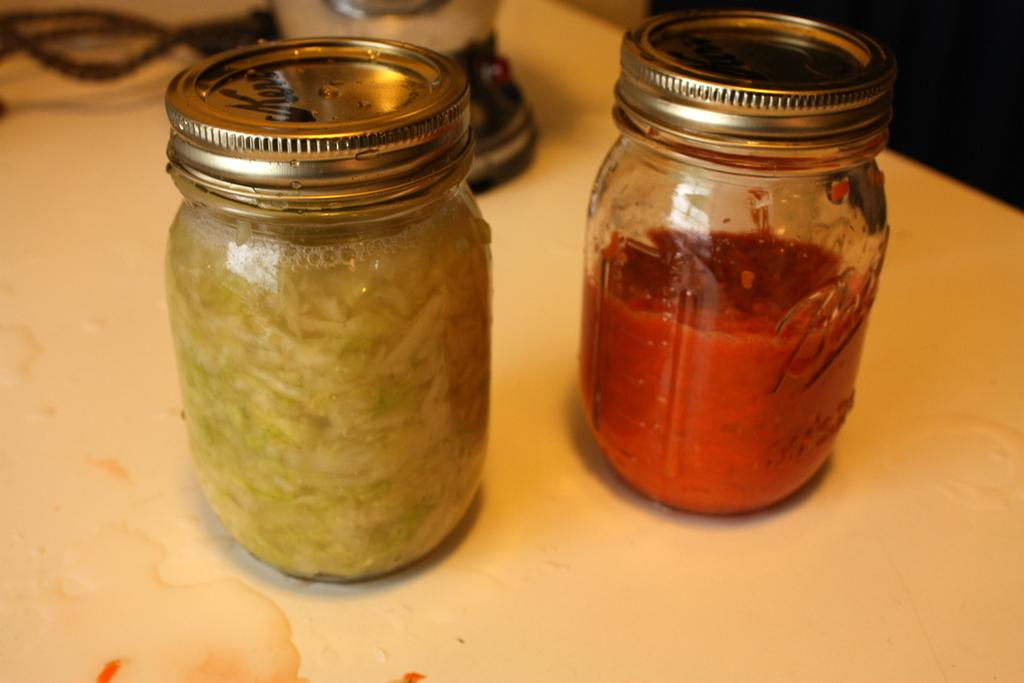What type of food items are contained in the jars in the image? There are sauces in jars in the image. How does the bell ring in the image? There is no bell present in the image. What is the mouth doing in the image? There is no mouth present in the image. 